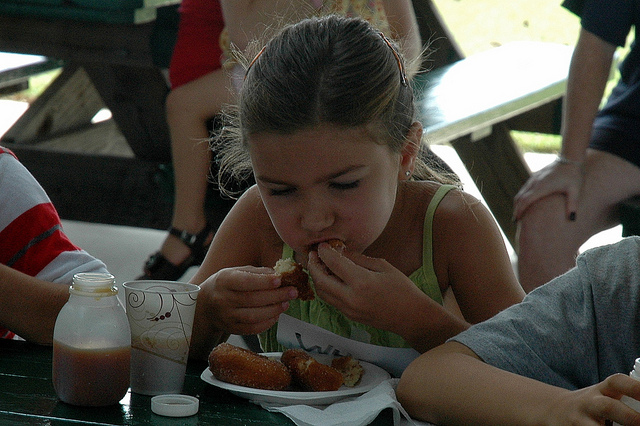What is the girl doing? The girl appears to be taking a bite out of a corn dog, a popular fairground snack, while sitting at a picnic table in an outdoor setting. 